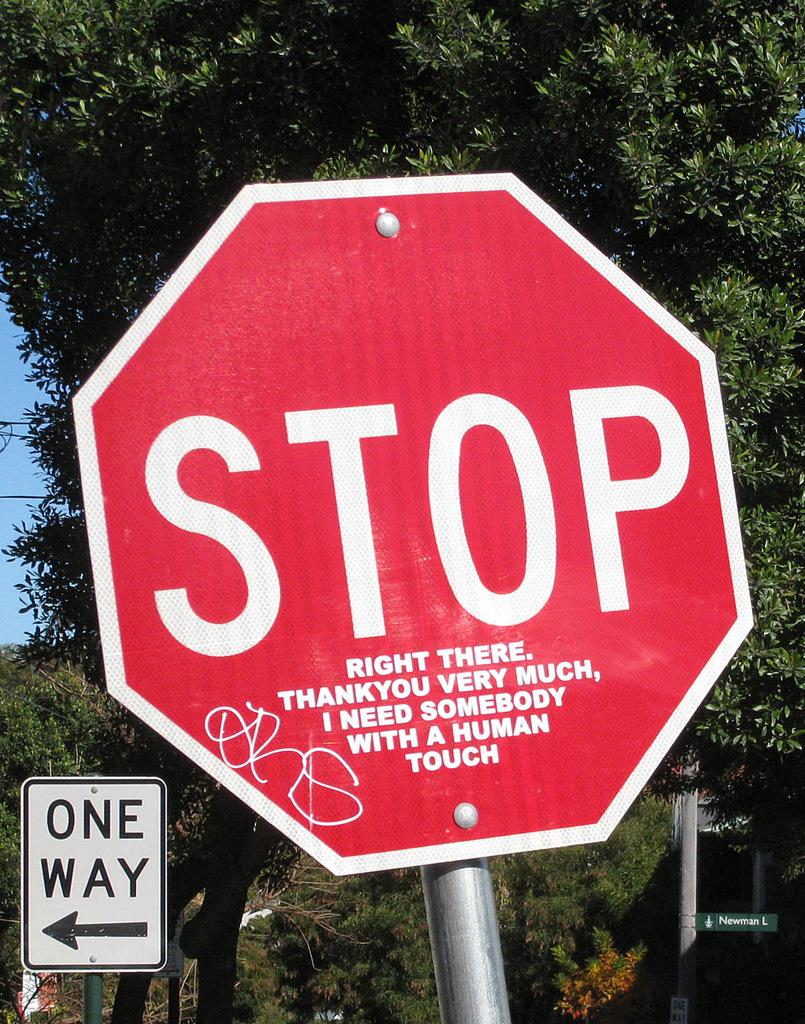<image>
Describe the image concisely. a stop sign that has a one way sign near it 